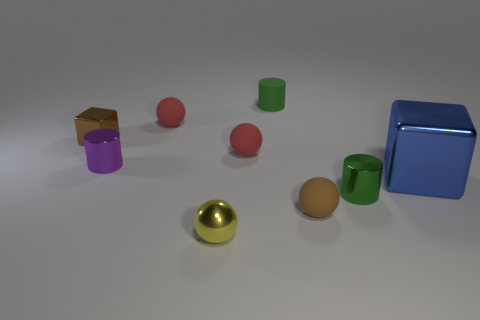Subtract all green balls. Subtract all yellow cylinders. How many balls are left? 4 Subtract all cylinders. How many objects are left? 6 Subtract all tiny brown balls. Subtract all brown objects. How many objects are left? 6 Add 4 yellow metallic balls. How many yellow metallic balls are left? 5 Add 1 yellow rubber things. How many yellow rubber things exist? 1 Subtract 0 red blocks. How many objects are left? 9 